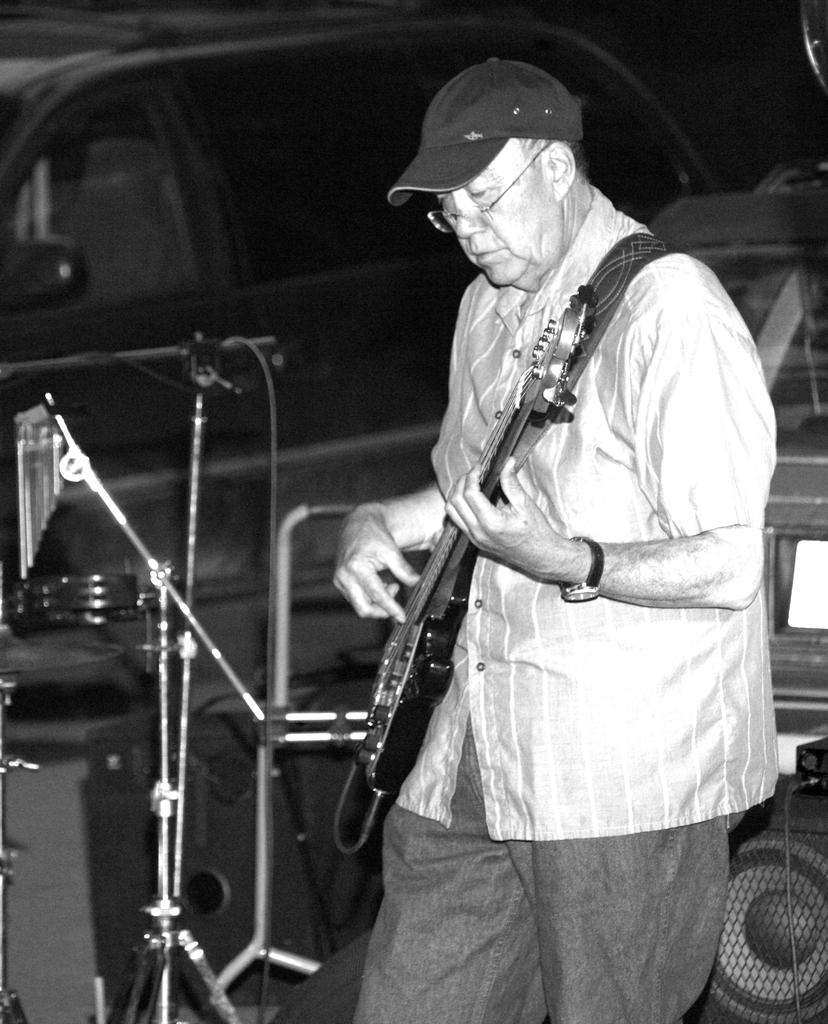Who is the main subject in the image? There is a man in the image. What is the man doing in the image? The man is standing and playing the guitar. What object is in front of the man? There is a microphone in front of the man. How many lizards can be seen crawling on the guitar in the image? There are no lizards present in the image, and therefore none can be seen crawling on the guitar. What type of basket is used to store the war supplies in the image? There is no mention of a basket or war supplies in the image; it features a man playing the guitar with a microphone in front of him. 